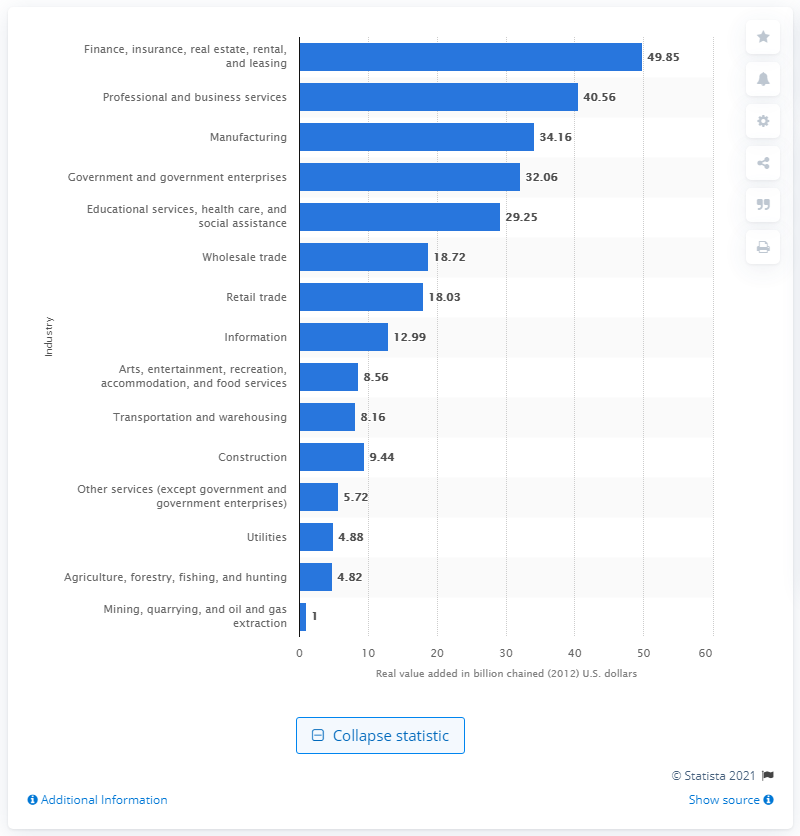Outline some significant characteristics in this image. In 2012, the manufacturing industry contributed a significant amount to Missouri's Gross Domestic Product, adding a value of 34.16. 